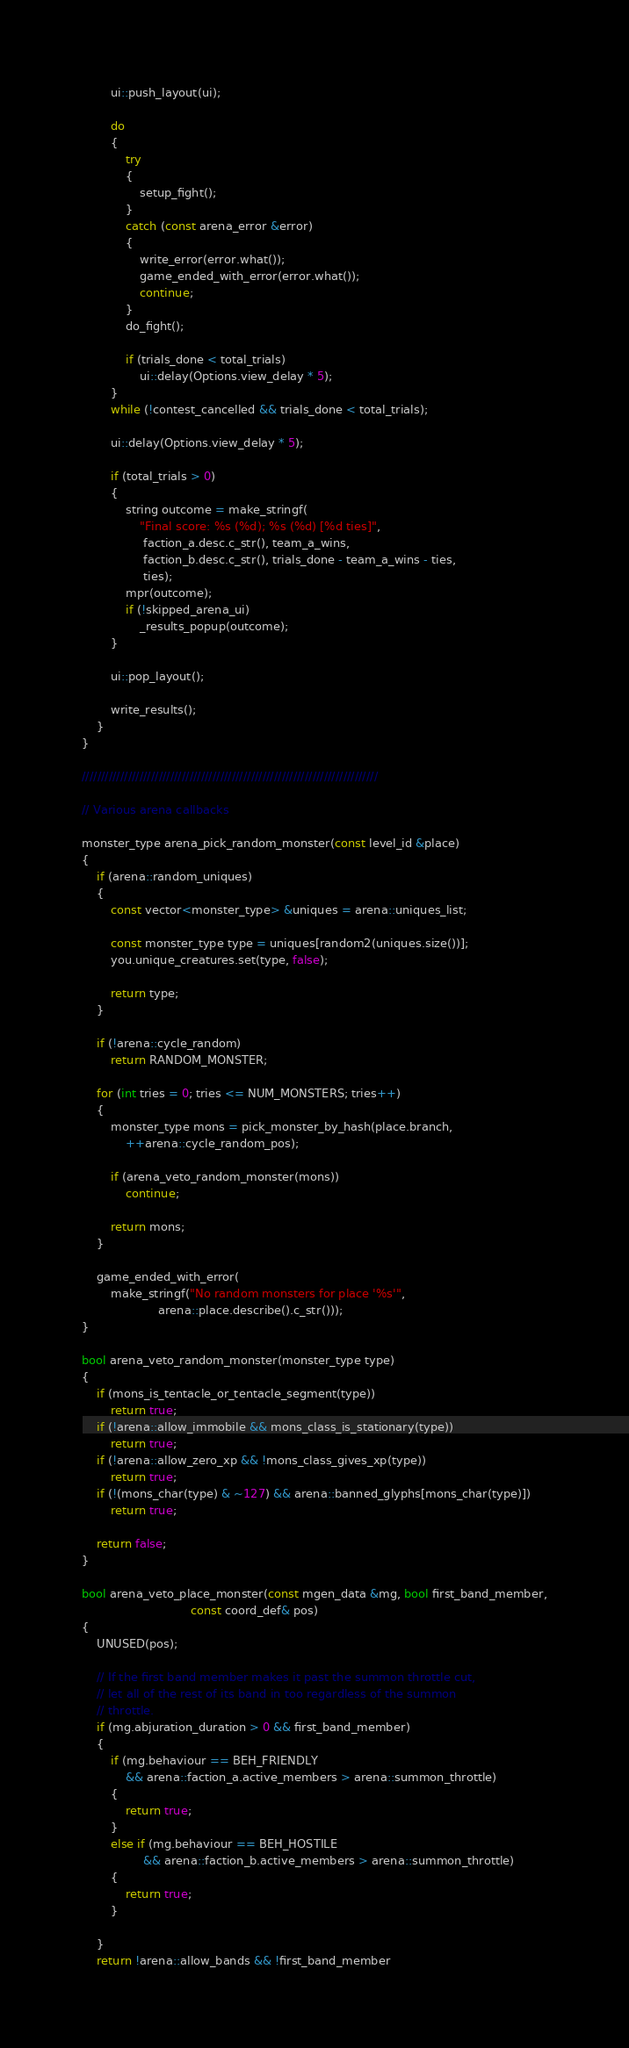Convert code to text. <code><loc_0><loc_0><loc_500><loc_500><_C++_>        ui::push_layout(ui);

        do
        {
            try
            {
                setup_fight();
            }
            catch (const arena_error &error)
            {
                write_error(error.what());
                game_ended_with_error(error.what());
                continue;
            }
            do_fight();

            if (trials_done < total_trials)
                ui::delay(Options.view_delay * 5);
        }
        while (!contest_cancelled && trials_done < total_trials);

        ui::delay(Options.view_delay * 5);

        if (total_trials > 0)
        {
            string outcome = make_stringf(
                "Final score: %s (%d); %s (%d) [%d ties]",
                 faction_a.desc.c_str(), team_a_wins,
                 faction_b.desc.c_str(), trials_done - team_a_wins - ties,
                 ties);
            mpr(outcome);
            if (!skipped_arena_ui)
                _results_popup(outcome);
        }

        ui::pop_layout();

        write_results();
    }
}

/////////////////////////////////////////////////////////////////////////////

// Various arena callbacks

monster_type arena_pick_random_monster(const level_id &place)
{
    if (arena::random_uniques)
    {
        const vector<monster_type> &uniques = arena::uniques_list;

        const monster_type type = uniques[random2(uniques.size())];
        you.unique_creatures.set(type, false);

        return type;
    }

    if (!arena::cycle_random)
        return RANDOM_MONSTER;

    for (int tries = 0; tries <= NUM_MONSTERS; tries++)
    {
        monster_type mons = pick_monster_by_hash(place.branch,
            ++arena::cycle_random_pos);

        if (arena_veto_random_monster(mons))
            continue;

        return mons;
    }

    game_ended_with_error(
        make_stringf("No random monsters for place '%s'",
                     arena::place.describe().c_str()));
}

bool arena_veto_random_monster(monster_type type)
{
    if (mons_is_tentacle_or_tentacle_segment(type))
        return true;
    if (!arena::allow_immobile && mons_class_is_stationary(type))
        return true;
    if (!arena::allow_zero_xp && !mons_class_gives_xp(type))
        return true;
    if (!(mons_char(type) & ~127) && arena::banned_glyphs[mons_char(type)])
        return true;

    return false;
}

bool arena_veto_place_monster(const mgen_data &mg, bool first_band_member,
                              const coord_def& pos)
{
    UNUSED(pos);

    // If the first band member makes it past the summon throttle cut,
    // let all of the rest of its band in too regardless of the summon
    // throttle.
    if (mg.abjuration_duration > 0 && first_band_member)
    {
        if (mg.behaviour == BEH_FRIENDLY
            && arena::faction_a.active_members > arena::summon_throttle)
        {
            return true;
        }
        else if (mg.behaviour == BEH_HOSTILE
                 && arena::faction_b.active_members > arena::summon_throttle)
        {
            return true;
        }

    }
    return !arena::allow_bands && !first_band_member</code> 